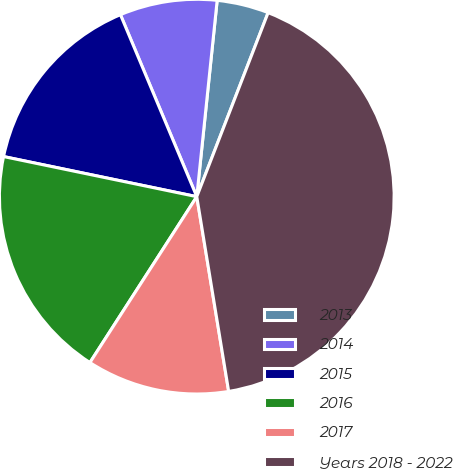Convert chart to OTSL. <chart><loc_0><loc_0><loc_500><loc_500><pie_chart><fcel>2013<fcel>2014<fcel>2015<fcel>2016<fcel>2017<fcel>Years 2018 - 2022<nl><fcel>4.24%<fcel>7.97%<fcel>15.42%<fcel>19.15%<fcel>11.69%<fcel>41.53%<nl></chart> 